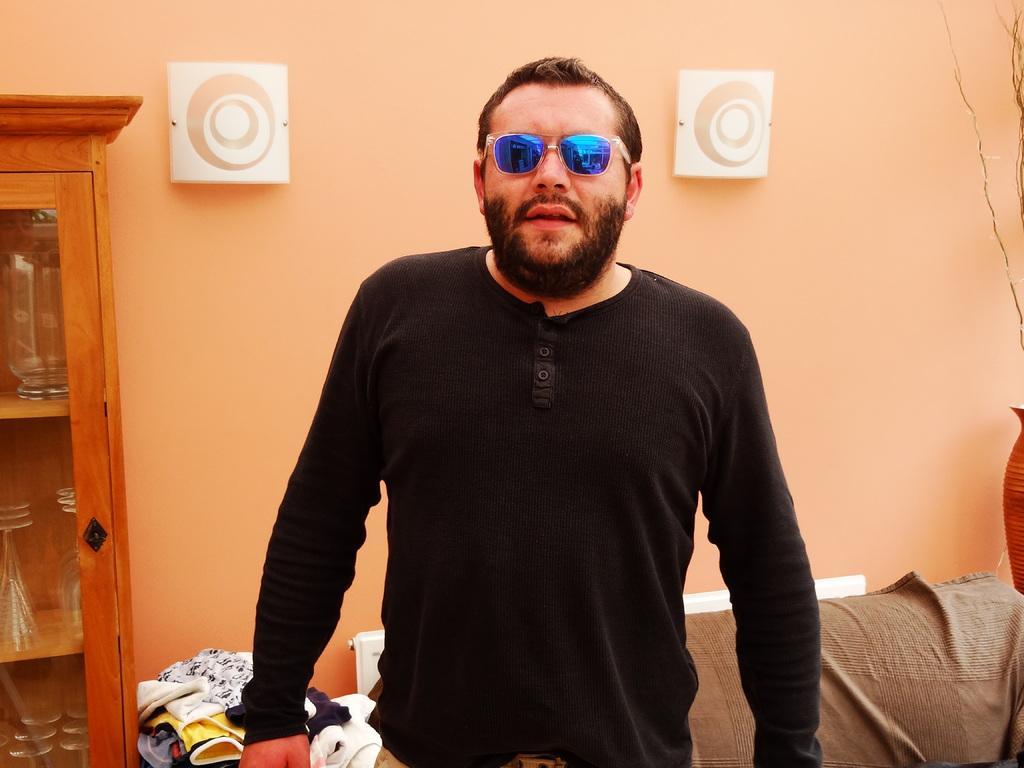Could you give a brief overview of what you see in this image? In this picture we can see a man, he wore spectacles and a black color t-shirt, behind to him we can see a sofa, cloths and few glasses in the racks, and also we can see few things on the wall. 